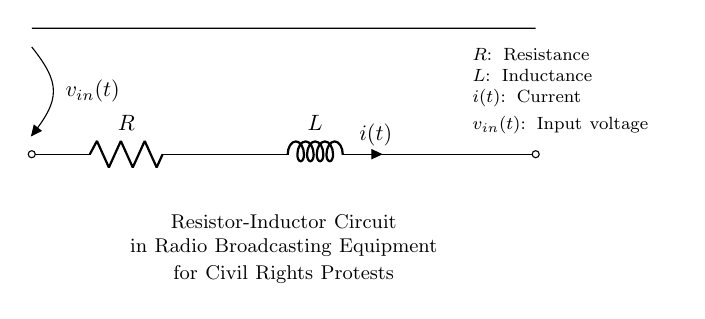What are the components in this circuit? The circuit contains a resistor and an inductor, which are fundamental components of a resistor-inductor circuit. The resistor is labeled as R, and the inductor is labeled as L.
Answer: Resistor and Inductor What does the current i(t) represent? In this circuit, i(t) represents the instantaneous current flowing through the inductor at any time t. The current can vary with the input voltage and the values of the resistor and inductor.
Answer: Instantaneous current What is the input voltage v_in(t)? The input voltage v_in(t) is the voltage source applied to the circuit, which influences the current flowing through the resistor and inductor. It is shown as v_in(t) at the left side of the diagram.
Answer: Voltage source How are the resistor and inductor connected? The resistor and inductor are connected in series, meaning the current flows through the resistor first and then through the inductor. This is indicated by the direct connection from one component to the other in the circuit diagram.
Answer: In series What effect does increasing the inductance L have on current? Increasing the inductance L in a resistor-inductor circuit generally results in a slower rate of change of current in response to changes in voltage, according to the inductor's property of opposing changes in current. This can be analyzed using the formula governing an inductor’s behavior in an RL circuit.
Answer: Slower rate of change What is the significance of this circuit type for radio broadcasting? The resistor-inductor circuit is vital in radio broadcasting for filtering and tuning applications, as it helps to shape the signal by controlling the frequency response and ensuring clarity in transmission, which is important during civil rights protests.
Answer: Signal filtering 